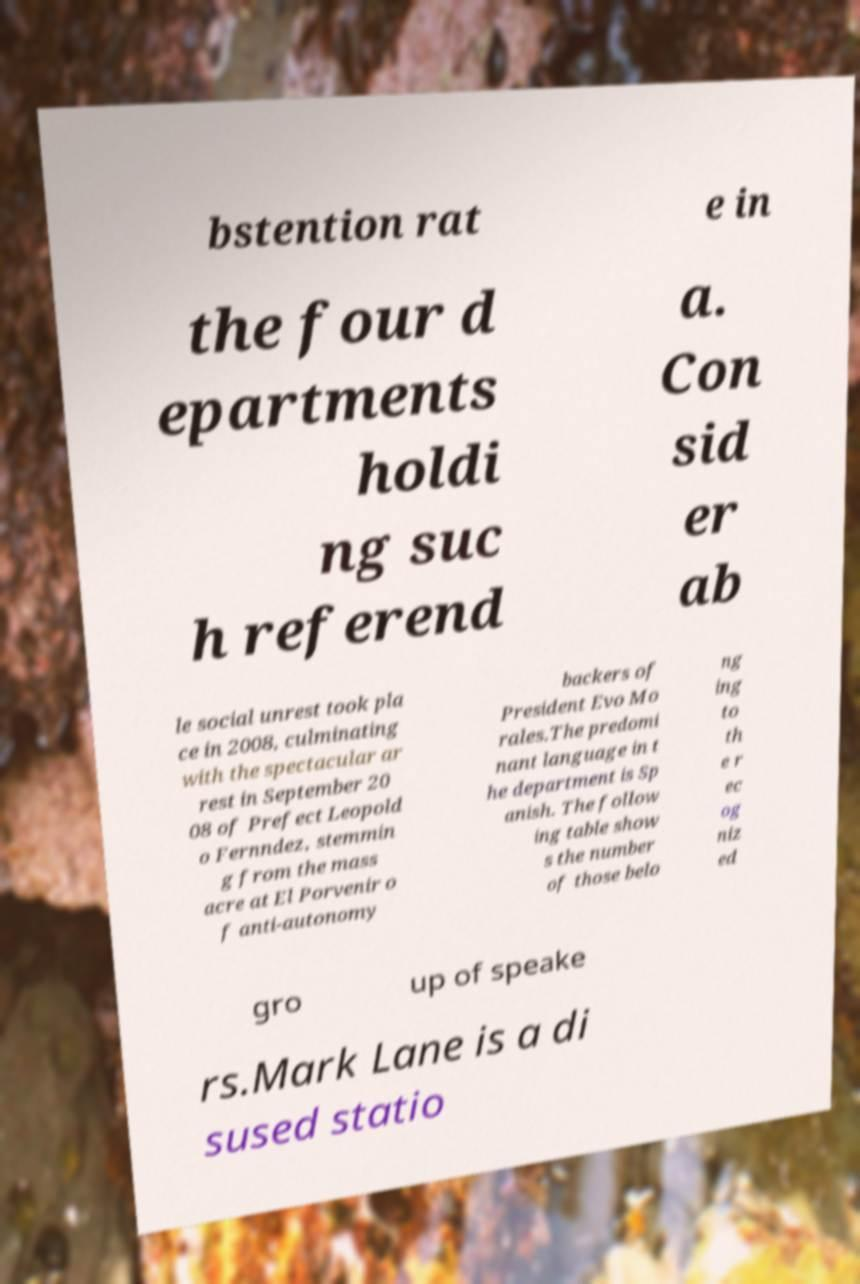I need the written content from this picture converted into text. Can you do that? bstention rat e in the four d epartments holdi ng suc h referend a. Con sid er ab le social unrest took pla ce in 2008, culminating with the spectacular ar rest in September 20 08 of Prefect Leopold o Fernndez, stemmin g from the mass acre at El Porvenir o f anti-autonomy backers of President Evo Mo rales.The predomi nant language in t he department is Sp anish. The follow ing table show s the number of those belo ng ing to th e r ec og niz ed gro up of speake rs.Mark Lane is a di sused statio 